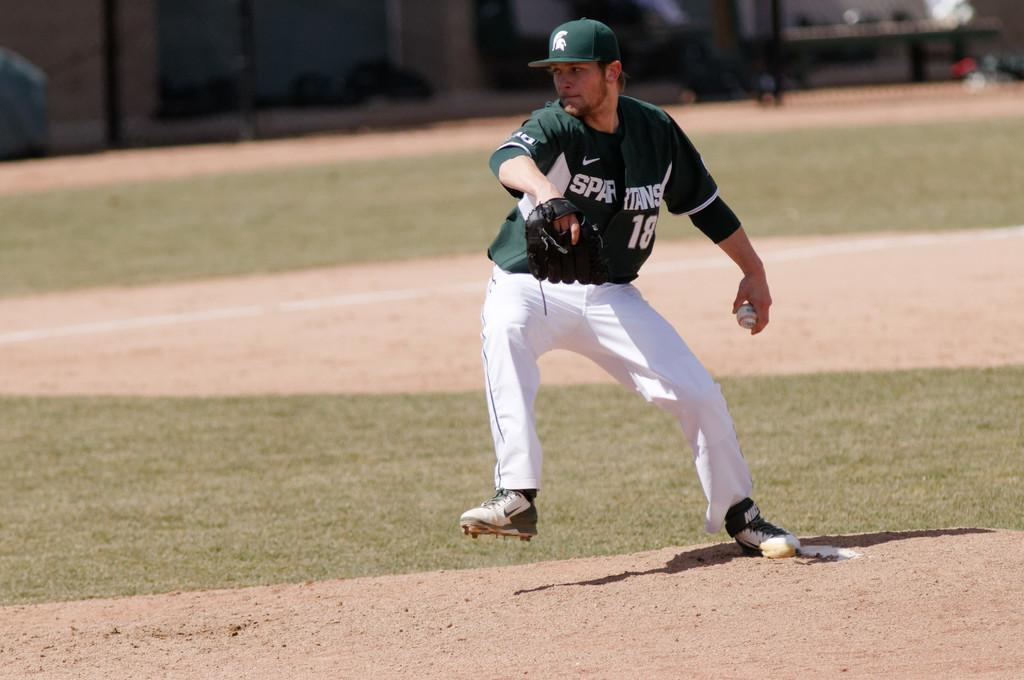<image>
Describe the image concisely. The Spartans pitcher prepares to throw a baseball from the mound. 